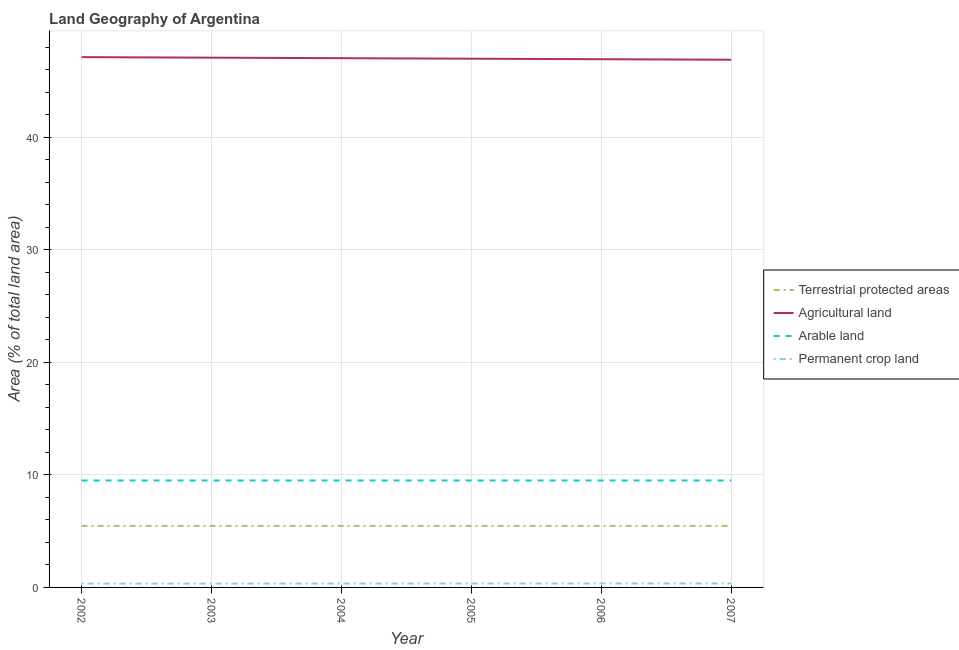How many different coloured lines are there?
Your answer should be very brief. 4. Does the line corresponding to percentage of area under arable land intersect with the line corresponding to percentage of area under permanent crop land?
Provide a succinct answer. No. What is the percentage of area under arable land in 2003?
Provide a short and direct response. 9.5. Across all years, what is the maximum percentage of area under agricultural land?
Provide a short and direct response. 47.1. Across all years, what is the minimum percentage of area under arable land?
Your answer should be compact. 9.5. What is the total percentage of area under agricultural land in the graph?
Make the answer very short. 281.92. What is the difference between the percentage of land under terrestrial protection in 2002 and the percentage of area under arable land in 2007?
Your response must be concise. -4.03. What is the average percentage of area under permanent crop land per year?
Ensure brevity in your answer.  0.35. In the year 2005, what is the difference between the percentage of area under permanent crop land and percentage of area under arable land?
Keep it short and to the point. -9.15. In how many years, is the percentage of land under terrestrial protection greater than 24 %?
Your answer should be very brief. 0. What is the ratio of the percentage of area under arable land in 2005 to that in 2006?
Offer a very short reply. 1. Is the percentage of area under arable land in 2002 less than that in 2005?
Give a very brief answer. No. Is the difference between the percentage of area under agricultural land in 2004 and 2005 greater than the difference between the percentage of land under terrestrial protection in 2004 and 2005?
Keep it short and to the point. Yes. What is the difference between the highest and the lowest percentage of land under terrestrial protection?
Keep it short and to the point. 0. Is the percentage of area under agricultural land strictly greater than the percentage of land under terrestrial protection over the years?
Your answer should be compact. Yes. Does the graph contain any zero values?
Your response must be concise. No. Does the graph contain grids?
Make the answer very short. Yes. How are the legend labels stacked?
Make the answer very short. Vertical. What is the title of the graph?
Offer a very short reply. Land Geography of Argentina. What is the label or title of the X-axis?
Keep it short and to the point. Year. What is the label or title of the Y-axis?
Ensure brevity in your answer.  Area (% of total land area). What is the Area (% of total land area) in Terrestrial protected areas in 2002?
Ensure brevity in your answer.  5.47. What is the Area (% of total land area) in Agricultural land in 2002?
Your answer should be very brief. 47.1. What is the Area (% of total land area) of Arable land in 2002?
Your answer should be very brief. 9.5. What is the Area (% of total land area) in Permanent crop land in 2002?
Your answer should be compact. 0.34. What is the Area (% of total land area) in Terrestrial protected areas in 2003?
Provide a succinct answer. 5.47. What is the Area (% of total land area) of Agricultural land in 2003?
Provide a short and direct response. 47.06. What is the Area (% of total land area) in Arable land in 2003?
Provide a short and direct response. 9.5. What is the Area (% of total land area) in Permanent crop land in 2003?
Ensure brevity in your answer.  0.35. What is the Area (% of total land area) in Terrestrial protected areas in 2004?
Your response must be concise. 5.47. What is the Area (% of total land area) in Agricultural land in 2004?
Offer a terse response. 47.01. What is the Area (% of total land area) in Arable land in 2004?
Make the answer very short. 9.5. What is the Area (% of total land area) of Permanent crop land in 2004?
Provide a succinct answer. 0.35. What is the Area (% of total land area) of Terrestrial protected areas in 2005?
Your answer should be very brief. 5.47. What is the Area (% of total land area) of Agricultural land in 2005?
Give a very brief answer. 46.96. What is the Area (% of total land area) in Arable land in 2005?
Your answer should be very brief. 9.5. What is the Area (% of total land area) in Permanent crop land in 2005?
Ensure brevity in your answer.  0.35. What is the Area (% of total land area) in Terrestrial protected areas in 2006?
Offer a terse response. 5.47. What is the Area (% of total land area) in Agricultural land in 2006?
Ensure brevity in your answer.  46.92. What is the Area (% of total land area) in Arable land in 2006?
Offer a terse response. 9.5. What is the Area (% of total land area) in Permanent crop land in 2006?
Your response must be concise. 0.35. What is the Area (% of total land area) in Terrestrial protected areas in 2007?
Keep it short and to the point. 5.47. What is the Area (% of total land area) in Agricultural land in 2007?
Offer a very short reply. 46.87. What is the Area (% of total land area) of Arable land in 2007?
Offer a very short reply. 9.5. What is the Area (% of total land area) of Permanent crop land in 2007?
Keep it short and to the point. 0.35. Across all years, what is the maximum Area (% of total land area) of Terrestrial protected areas?
Your answer should be very brief. 5.47. Across all years, what is the maximum Area (% of total land area) in Agricultural land?
Make the answer very short. 47.1. Across all years, what is the maximum Area (% of total land area) of Arable land?
Offer a very short reply. 9.5. Across all years, what is the maximum Area (% of total land area) of Permanent crop land?
Your answer should be compact. 0.35. Across all years, what is the minimum Area (% of total land area) in Terrestrial protected areas?
Provide a short and direct response. 5.47. Across all years, what is the minimum Area (% of total land area) of Agricultural land?
Give a very brief answer. 46.87. Across all years, what is the minimum Area (% of total land area) in Arable land?
Ensure brevity in your answer.  9.5. Across all years, what is the minimum Area (% of total land area) of Permanent crop land?
Your response must be concise. 0.34. What is the total Area (% of total land area) of Terrestrial protected areas in the graph?
Your response must be concise. 32.8. What is the total Area (% of total land area) of Agricultural land in the graph?
Your answer should be very brief. 281.92. What is the total Area (% of total land area) in Arable land in the graph?
Provide a short and direct response. 57. What is the total Area (% of total land area) in Permanent crop land in the graph?
Provide a short and direct response. 2.09. What is the difference between the Area (% of total land area) of Agricultural land in 2002 and that in 2003?
Make the answer very short. 0.05. What is the difference between the Area (% of total land area) in Arable land in 2002 and that in 2003?
Offer a very short reply. 0. What is the difference between the Area (% of total land area) in Permanent crop land in 2002 and that in 2003?
Give a very brief answer. -0. What is the difference between the Area (% of total land area) in Terrestrial protected areas in 2002 and that in 2004?
Ensure brevity in your answer.  0. What is the difference between the Area (% of total land area) in Agricultural land in 2002 and that in 2004?
Keep it short and to the point. 0.09. What is the difference between the Area (% of total land area) of Permanent crop land in 2002 and that in 2004?
Your response must be concise. -0. What is the difference between the Area (% of total land area) in Agricultural land in 2002 and that in 2005?
Keep it short and to the point. 0.14. What is the difference between the Area (% of total land area) in Permanent crop land in 2002 and that in 2005?
Provide a short and direct response. -0.01. What is the difference between the Area (% of total land area) of Terrestrial protected areas in 2002 and that in 2006?
Offer a terse response. 0. What is the difference between the Area (% of total land area) in Agricultural land in 2002 and that in 2006?
Give a very brief answer. 0.18. What is the difference between the Area (% of total land area) of Arable land in 2002 and that in 2006?
Offer a terse response. 0. What is the difference between the Area (% of total land area) of Permanent crop land in 2002 and that in 2006?
Your response must be concise. -0.01. What is the difference between the Area (% of total land area) of Terrestrial protected areas in 2002 and that in 2007?
Provide a short and direct response. 0. What is the difference between the Area (% of total land area) of Agricultural land in 2002 and that in 2007?
Make the answer very short. 0.23. What is the difference between the Area (% of total land area) in Permanent crop land in 2002 and that in 2007?
Make the answer very short. -0.01. What is the difference between the Area (% of total land area) in Agricultural land in 2003 and that in 2004?
Your answer should be compact. 0.05. What is the difference between the Area (% of total land area) in Permanent crop land in 2003 and that in 2004?
Offer a terse response. -0. What is the difference between the Area (% of total land area) of Agricultural land in 2003 and that in 2005?
Your answer should be compact. 0.09. What is the difference between the Area (% of total land area) of Permanent crop land in 2003 and that in 2005?
Give a very brief answer. -0. What is the difference between the Area (% of total land area) in Terrestrial protected areas in 2003 and that in 2006?
Give a very brief answer. 0. What is the difference between the Area (% of total land area) of Agricultural land in 2003 and that in 2006?
Keep it short and to the point. 0.14. What is the difference between the Area (% of total land area) of Arable land in 2003 and that in 2006?
Give a very brief answer. 0. What is the difference between the Area (% of total land area) in Permanent crop land in 2003 and that in 2006?
Offer a terse response. -0.01. What is the difference between the Area (% of total land area) of Terrestrial protected areas in 2003 and that in 2007?
Provide a short and direct response. 0. What is the difference between the Area (% of total land area) in Agricultural land in 2003 and that in 2007?
Your answer should be compact. 0.18. What is the difference between the Area (% of total land area) of Permanent crop land in 2003 and that in 2007?
Your answer should be very brief. -0.01. What is the difference between the Area (% of total land area) in Terrestrial protected areas in 2004 and that in 2005?
Your answer should be very brief. 0. What is the difference between the Area (% of total land area) in Agricultural land in 2004 and that in 2005?
Provide a succinct answer. 0.05. What is the difference between the Area (% of total land area) of Arable land in 2004 and that in 2005?
Offer a terse response. 0. What is the difference between the Area (% of total land area) of Permanent crop land in 2004 and that in 2005?
Keep it short and to the point. -0. What is the difference between the Area (% of total land area) in Agricultural land in 2004 and that in 2006?
Ensure brevity in your answer.  0.09. What is the difference between the Area (% of total land area) of Arable land in 2004 and that in 2006?
Your answer should be compact. 0. What is the difference between the Area (% of total land area) of Permanent crop land in 2004 and that in 2006?
Provide a succinct answer. -0. What is the difference between the Area (% of total land area) of Agricultural land in 2004 and that in 2007?
Your answer should be compact. 0.14. What is the difference between the Area (% of total land area) in Arable land in 2004 and that in 2007?
Give a very brief answer. 0. What is the difference between the Area (% of total land area) of Permanent crop land in 2004 and that in 2007?
Your response must be concise. -0.01. What is the difference between the Area (% of total land area) of Agricultural land in 2005 and that in 2006?
Make the answer very short. 0.05. What is the difference between the Area (% of total land area) of Permanent crop land in 2005 and that in 2006?
Offer a terse response. -0. What is the difference between the Area (% of total land area) of Agricultural land in 2005 and that in 2007?
Your answer should be very brief. 0.09. What is the difference between the Area (% of total land area) of Permanent crop land in 2005 and that in 2007?
Offer a terse response. -0. What is the difference between the Area (% of total land area) in Terrestrial protected areas in 2006 and that in 2007?
Keep it short and to the point. 0. What is the difference between the Area (% of total land area) of Agricultural land in 2006 and that in 2007?
Keep it short and to the point. 0.05. What is the difference between the Area (% of total land area) of Arable land in 2006 and that in 2007?
Keep it short and to the point. 0. What is the difference between the Area (% of total land area) in Permanent crop land in 2006 and that in 2007?
Ensure brevity in your answer.  -0. What is the difference between the Area (% of total land area) in Terrestrial protected areas in 2002 and the Area (% of total land area) in Agricultural land in 2003?
Ensure brevity in your answer.  -41.59. What is the difference between the Area (% of total land area) in Terrestrial protected areas in 2002 and the Area (% of total land area) in Arable land in 2003?
Make the answer very short. -4.03. What is the difference between the Area (% of total land area) in Terrestrial protected areas in 2002 and the Area (% of total land area) in Permanent crop land in 2003?
Offer a terse response. 5.12. What is the difference between the Area (% of total land area) in Agricultural land in 2002 and the Area (% of total land area) in Arable land in 2003?
Offer a terse response. 37.6. What is the difference between the Area (% of total land area) of Agricultural land in 2002 and the Area (% of total land area) of Permanent crop land in 2003?
Provide a short and direct response. 46.76. What is the difference between the Area (% of total land area) of Arable land in 2002 and the Area (% of total land area) of Permanent crop land in 2003?
Ensure brevity in your answer.  9.15. What is the difference between the Area (% of total land area) of Terrestrial protected areas in 2002 and the Area (% of total land area) of Agricultural land in 2004?
Give a very brief answer. -41.54. What is the difference between the Area (% of total land area) in Terrestrial protected areas in 2002 and the Area (% of total land area) in Arable land in 2004?
Offer a terse response. -4.03. What is the difference between the Area (% of total land area) of Terrestrial protected areas in 2002 and the Area (% of total land area) of Permanent crop land in 2004?
Ensure brevity in your answer.  5.12. What is the difference between the Area (% of total land area) of Agricultural land in 2002 and the Area (% of total land area) of Arable land in 2004?
Your response must be concise. 37.6. What is the difference between the Area (% of total land area) in Agricultural land in 2002 and the Area (% of total land area) in Permanent crop land in 2004?
Keep it short and to the point. 46.75. What is the difference between the Area (% of total land area) in Arable land in 2002 and the Area (% of total land area) in Permanent crop land in 2004?
Ensure brevity in your answer.  9.15. What is the difference between the Area (% of total land area) in Terrestrial protected areas in 2002 and the Area (% of total land area) in Agricultural land in 2005?
Your answer should be compact. -41.5. What is the difference between the Area (% of total land area) in Terrestrial protected areas in 2002 and the Area (% of total land area) in Arable land in 2005?
Give a very brief answer. -4.03. What is the difference between the Area (% of total land area) of Terrestrial protected areas in 2002 and the Area (% of total land area) of Permanent crop land in 2005?
Provide a short and direct response. 5.12. What is the difference between the Area (% of total land area) in Agricultural land in 2002 and the Area (% of total land area) in Arable land in 2005?
Offer a very short reply. 37.6. What is the difference between the Area (% of total land area) in Agricultural land in 2002 and the Area (% of total land area) in Permanent crop land in 2005?
Provide a succinct answer. 46.75. What is the difference between the Area (% of total land area) of Arable land in 2002 and the Area (% of total land area) of Permanent crop land in 2005?
Ensure brevity in your answer.  9.15. What is the difference between the Area (% of total land area) in Terrestrial protected areas in 2002 and the Area (% of total land area) in Agricultural land in 2006?
Your answer should be very brief. -41.45. What is the difference between the Area (% of total land area) in Terrestrial protected areas in 2002 and the Area (% of total land area) in Arable land in 2006?
Your answer should be compact. -4.03. What is the difference between the Area (% of total land area) of Terrestrial protected areas in 2002 and the Area (% of total land area) of Permanent crop land in 2006?
Make the answer very short. 5.11. What is the difference between the Area (% of total land area) in Agricultural land in 2002 and the Area (% of total land area) in Arable land in 2006?
Offer a terse response. 37.6. What is the difference between the Area (% of total land area) of Agricultural land in 2002 and the Area (% of total land area) of Permanent crop land in 2006?
Keep it short and to the point. 46.75. What is the difference between the Area (% of total land area) of Arable land in 2002 and the Area (% of total land area) of Permanent crop land in 2006?
Your response must be concise. 9.15. What is the difference between the Area (% of total land area) of Terrestrial protected areas in 2002 and the Area (% of total land area) of Agricultural land in 2007?
Make the answer very short. -41.4. What is the difference between the Area (% of total land area) of Terrestrial protected areas in 2002 and the Area (% of total land area) of Arable land in 2007?
Your answer should be very brief. -4.03. What is the difference between the Area (% of total land area) in Terrestrial protected areas in 2002 and the Area (% of total land area) in Permanent crop land in 2007?
Make the answer very short. 5.11. What is the difference between the Area (% of total land area) in Agricultural land in 2002 and the Area (% of total land area) in Arable land in 2007?
Provide a succinct answer. 37.6. What is the difference between the Area (% of total land area) of Agricultural land in 2002 and the Area (% of total land area) of Permanent crop land in 2007?
Provide a succinct answer. 46.75. What is the difference between the Area (% of total land area) in Arable land in 2002 and the Area (% of total land area) in Permanent crop land in 2007?
Your answer should be very brief. 9.15. What is the difference between the Area (% of total land area) in Terrestrial protected areas in 2003 and the Area (% of total land area) in Agricultural land in 2004?
Provide a short and direct response. -41.54. What is the difference between the Area (% of total land area) of Terrestrial protected areas in 2003 and the Area (% of total land area) of Arable land in 2004?
Give a very brief answer. -4.03. What is the difference between the Area (% of total land area) of Terrestrial protected areas in 2003 and the Area (% of total land area) of Permanent crop land in 2004?
Provide a succinct answer. 5.12. What is the difference between the Area (% of total land area) of Agricultural land in 2003 and the Area (% of total land area) of Arable land in 2004?
Offer a very short reply. 37.55. What is the difference between the Area (% of total land area) of Agricultural land in 2003 and the Area (% of total land area) of Permanent crop land in 2004?
Provide a short and direct response. 46.71. What is the difference between the Area (% of total land area) of Arable land in 2003 and the Area (% of total land area) of Permanent crop land in 2004?
Give a very brief answer. 9.15. What is the difference between the Area (% of total land area) of Terrestrial protected areas in 2003 and the Area (% of total land area) of Agricultural land in 2005?
Your answer should be very brief. -41.5. What is the difference between the Area (% of total land area) in Terrestrial protected areas in 2003 and the Area (% of total land area) in Arable land in 2005?
Give a very brief answer. -4.03. What is the difference between the Area (% of total land area) of Terrestrial protected areas in 2003 and the Area (% of total land area) of Permanent crop land in 2005?
Provide a succinct answer. 5.12. What is the difference between the Area (% of total land area) in Agricultural land in 2003 and the Area (% of total land area) in Arable land in 2005?
Offer a very short reply. 37.55. What is the difference between the Area (% of total land area) of Agricultural land in 2003 and the Area (% of total land area) of Permanent crop land in 2005?
Ensure brevity in your answer.  46.71. What is the difference between the Area (% of total land area) in Arable land in 2003 and the Area (% of total land area) in Permanent crop land in 2005?
Keep it short and to the point. 9.15. What is the difference between the Area (% of total land area) in Terrestrial protected areas in 2003 and the Area (% of total land area) in Agricultural land in 2006?
Keep it short and to the point. -41.45. What is the difference between the Area (% of total land area) in Terrestrial protected areas in 2003 and the Area (% of total land area) in Arable land in 2006?
Your response must be concise. -4.03. What is the difference between the Area (% of total land area) in Terrestrial protected areas in 2003 and the Area (% of total land area) in Permanent crop land in 2006?
Give a very brief answer. 5.11. What is the difference between the Area (% of total land area) in Agricultural land in 2003 and the Area (% of total land area) in Arable land in 2006?
Your answer should be compact. 37.55. What is the difference between the Area (% of total land area) in Agricultural land in 2003 and the Area (% of total land area) in Permanent crop land in 2006?
Your answer should be compact. 46.7. What is the difference between the Area (% of total land area) in Arable land in 2003 and the Area (% of total land area) in Permanent crop land in 2006?
Ensure brevity in your answer.  9.15. What is the difference between the Area (% of total land area) of Terrestrial protected areas in 2003 and the Area (% of total land area) of Agricultural land in 2007?
Offer a terse response. -41.4. What is the difference between the Area (% of total land area) in Terrestrial protected areas in 2003 and the Area (% of total land area) in Arable land in 2007?
Ensure brevity in your answer.  -4.03. What is the difference between the Area (% of total land area) of Terrestrial protected areas in 2003 and the Area (% of total land area) of Permanent crop land in 2007?
Offer a terse response. 5.11. What is the difference between the Area (% of total land area) of Agricultural land in 2003 and the Area (% of total land area) of Arable land in 2007?
Make the answer very short. 37.55. What is the difference between the Area (% of total land area) in Agricultural land in 2003 and the Area (% of total land area) in Permanent crop land in 2007?
Make the answer very short. 46.7. What is the difference between the Area (% of total land area) of Arable land in 2003 and the Area (% of total land area) of Permanent crop land in 2007?
Keep it short and to the point. 9.15. What is the difference between the Area (% of total land area) in Terrestrial protected areas in 2004 and the Area (% of total land area) in Agricultural land in 2005?
Keep it short and to the point. -41.5. What is the difference between the Area (% of total land area) in Terrestrial protected areas in 2004 and the Area (% of total land area) in Arable land in 2005?
Your response must be concise. -4.03. What is the difference between the Area (% of total land area) in Terrestrial protected areas in 2004 and the Area (% of total land area) in Permanent crop land in 2005?
Your answer should be compact. 5.12. What is the difference between the Area (% of total land area) of Agricultural land in 2004 and the Area (% of total land area) of Arable land in 2005?
Give a very brief answer. 37.51. What is the difference between the Area (% of total land area) in Agricultural land in 2004 and the Area (% of total land area) in Permanent crop land in 2005?
Give a very brief answer. 46.66. What is the difference between the Area (% of total land area) in Arable land in 2004 and the Area (% of total land area) in Permanent crop land in 2005?
Ensure brevity in your answer.  9.15. What is the difference between the Area (% of total land area) in Terrestrial protected areas in 2004 and the Area (% of total land area) in Agricultural land in 2006?
Offer a very short reply. -41.45. What is the difference between the Area (% of total land area) in Terrestrial protected areas in 2004 and the Area (% of total land area) in Arable land in 2006?
Your response must be concise. -4.03. What is the difference between the Area (% of total land area) of Terrestrial protected areas in 2004 and the Area (% of total land area) of Permanent crop land in 2006?
Your response must be concise. 5.11. What is the difference between the Area (% of total land area) of Agricultural land in 2004 and the Area (% of total land area) of Arable land in 2006?
Provide a succinct answer. 37.51. What is the difference between the Area (% of total land area) of Agricultural land in 2004 and the Area (% of total land area) of Permanent crop land in 2006?
Your answer should be very brief. 46.66. What is the difference between the Area (% of total land area) in Arable land in 2004 and the Area (% of total land area) in Permanent crop land in 2006?
Make the answer very short. 9.15. What is the difference between the Area (% of total land area) of Terrestrial protected areas in 2004 and the Area (% of total land area) of Agricultural land in 2007?
Offer a terse response. -41.4. What is the difference between the Area (% of total land area) of Terrestrial protected areas in 2004 and the Area (% of total land area) of Arable land in 2007?
Ensure brevity in your answer.  -4.03. What is the difference between the Area (% of total land area) of Terrestrial protected areas in 2004 and the Area (% of total land area) of Permanent crop land in 2007?
Ensure brevity in your answer.  5.11. What is the difference between the Area (% of total land area) in Agricultural land in 2004 and the Area (% of total land area) in Arable land in 2007?
Provide a succinct answer. 37.51. What is the difference between the Area (% of total land area) of Agricultural land in 2004 and the Area (% of total land area) of Permanent crop land in 2007?
Make the answer very short. 46.66. What is the difference between the Area (% of total land area) in Arable land in 2004 and the Area (% of total land area) in Permanent crop land in 2007?
Your answer should be compact. 9.15. What is the difference between the Area (% of total land area) in Terrestrial protected areas in 2005 and the Area (% of total land area) in Agricultural land in 2006?
Give a very brief answer. -41.45. What is the difference between the Area (% of total land area) of Terrestrial protected areas in 2005 and the Area (% of total land area) of Arable land in 2006?
Offer a very short reply. -4.03. What is the difference between the Area (% of total land area) of Terrestrial protected areas in 2005 and the Area (% of total land area) of Permanent crop land in 2006?
Provide a succinct answer. 5.11. What is the difference between the Area (% of total land area) of Agricultural land in 2005 and the Area (% of total land area) of Arable land in 2006?
Keep it short and to the point. 37.46. What is the difference between the Area (% of total land area) in Agricultural land in 2005 and the Area (% of total land area) in Permanent crop land in 2006?
Make the answer very short. 46.61. What is the difference between the Area (% of total land area) of Arable land in 2005 and the Area (% of total land area) of Permanent crop land in 2006?
Ensure brevity in your answer.  9.15. What is the difference between the Area (% of total land area) in Terrestrial protected areas in 2005 and the Area (% of total land area) in Agricultural land in 2007?
Offer a very short reply. -41.4. What is the difference between the Area (% of total land area) in Terrestrial protected areas in 2005 and the Area (% of total land area) in Arable land in 2007?
Provide a succinct answer. -4.03. What is the difference between the Area (% of total land area) in Terrestrial protected areas in 2005 and the Area (% of total land area) in Permanent crop land in 2007?
Your answer should be very brief. 5.11. What is the difference between the Area (% of total land area) of Agricultural land in 2005 and the Area (% of total land area) of Arable land in 2007?
Provide a short and direct response. 37.46. What is the difference between the Area (% of total land area) of Agricultural land in 2005 and the Area (% of total land area) of Permanent crop land in 2007?
Offer a terse response. 46.61. What is the difference between the Area (% of total land area) of Arable land in 2005 and the Area (% of total land area) of Permanent crop land in 2007?
Offer a terse response. 9.15. What is the difference between the Area (% of total land area) of Terrestrial protected areas in 2006 and the Area (% of total land area) of Agricultural land in 2007?
Your response must be concise. -41.4. What is the difference between the Area (% of total land area) of Terrestrial protected areas in 2006 and the Area (% of total land area) of Arable land in 2007?
Keep it short and to the point. -4.03. What is the difference between the Area (% of total land area) of Terrestrial protected areas in 2006 and the Area (% of total land area) of Permanent crop land in 2007?
Provide a short and direct response. 5.11. What is the difference between the Area (% of total land area) in Agricultural land in 2006 and the Area (% of total land area) in Arable land in 2007?
Your answer should be compact. 37.42. What is the difference between the Area (% of total land area) of Agricultural land in 2006 and the Area (% of total land area) of Permanent crop land in 2007?
Provide a succinct answer. 46.56. What is the difference between the Area (% of total land area) of Arable land in 2006 and the Area (% of total land area) of Permanent crop land in 2007?
Offer a very short reply. 9.15. What is the average Area (% of total land area) in Terrestrial protected areas per year?
Offer a terse response. 5.47. What is the average Area (% of total land area) of Agricultural land per year?
Offer a very short reply. 46.99. What is the average Area (% of total land area) of Arable land per year?
Offer a very short reply. 9.5. What is the average Area (% of total land area) of Permanent crop land per year?
Provide a short and direct response. 0.35. In the year 2002, what is the difference between the Area (% of total land area) of Terrestrial protected areas and Area (% of total land area) of Agricultural land?
Ensure brevity in your answer.  -41.63. In the year 2002, what is the difference between the Area (% of total land area) in Terrestrial protected areas and Area (% of total land area) in Arable land?
Provide a short and direct response. -4.03. In the year 2002, what is the difference between the Area (% of total land area) in Terrestrial protected areas and Area (% of total land area) in Permanent crop land?
Ensure brevity in your answer.  5.12. In the year 2002, what is the difference between the Area (% of total land area) in Agricultural land and Area (% of total land area) in Arable land?
Offer a very short reply. 37.6. In the year 2002, what is the difference between the Area (% of total land area) in Agricultural land and Area (% of total land area) in Permanent crop land?
Ensure brevity in your answer.  46.76. In the year 2002, what is the difference between the Area (% of total land area) in Arable land and Area (% of total land area) in Permanent crop land?
Offer a very short reply. 9.16. In the year 2003, what is the difference between the Area (% of total land area) in Terrestrial protected areas and Area (% of total land area) in Agricultural land?
Provide a short and direct response. -41.59. In the year 2003, what is the difference between the Area (% of total land area) in Terrestrial protected areas and Area (% of total land area) in Arable land?
Offer a terse response. -4.03. In the year 2003, what is the difference between the Area (% of total land area) in Terrestrial protected areas and Area (% of total land area) in Permanent crop land?
Give a very brief answer. 5.12. In the year 2003, what is the difference between the Area (% of total land area) of Agricultural land and Area (% of total land area) of Arable land?
Provide a short and direct response. 37.55. In the year 2003, what is the difference between the Area (% of total land area) of Agricultural land and Area (% of total land area) of Permanent crop land?
Keep it short and to the point. 46.71. In the year 2003, what is the difference between the Area (% of total land area) of Arable land and Area (% of total land area) of Permanent crop land?
Provide a succinct answer. 9.15. In the year 2004, what is the difference between the Area (% of total land area) of Terrestrial protected areas and Area (% of total land area) of Agricultural land?
Provide a short and direct response. -41.54. In the year 2004, what is the difference between the Area (% of total land area) in Terrestrial protected areas and Area (% of total land area) in Arable land?
Ensure brevity in your answer.  -4.03. In the year 2004, what is the difference between the Area (% of total land area) in Terrestrial protected areas and Area (% of total land area) in Permanent crop land?
Make the answer very short. 5.12. In the year 2004, what is the difference between the Area (% of total land area) of Agricultural land and Area (% of total land area) of Arable land?
Keep it short and to the point. 37.51. In the year 2004, what is the difference between the Area (% of total land area) of Agricultural land and Area (% of total land area) of Permanent crop land?
Keep it short and to the point. 46.66. In the year 2004, what is the difference between the Area (% of total land area) of Arable land and Area (% of total land area) of Permanent crop land?
Your answer should be very brief. 9.15. In the year 2005, what is the difference between the Area (% of total land area) of Terrestrial protected areas and Area (% of total land area) of Agricultural land?
Ensure brevity in your answer.  -41.5. In the year 2005, what is the difference between the Area (% of total land area) of Terrestrial protected areas and Area (% of total land area) of Arable land?
Ensure brevity in your answer.  -4.03. In the year 2005, what is the difference between the Area (% of total land area) in Terrestrial protected areas and Area (% of total land area) in Permanent crop land?
Give a very brief answer. 5.12. In the year 2005, what is the difference between the Area (% of total land area) in Agricultural land and Area (% of total land area) in Arable land?
Give a very brief answer. 37.46. In the year 2005, what is the difference between the Area (% of total land area) of Agricultural land and Area (% of total land area) of Permanent crop land?
Keep it short and to the point. 46.61. In the year 2005, what is the difference between the Area (% of total land area) in Arable land and Area (% of total land area) in Permanent crop land?
Your response must be concise. 9.15. In the year 2006, what is the difference between the Area (% of total land area) of Terrestrial protected areas and Area (% of total land area) of Agricultural land?
Your answer should be compact. -41.45. In the year 2006, what is the difference between the Area (% of total land area) of Terrestrial protected areas and Area (% of total land area) of Arable land?
Keep it short and to the point. -4.03. In the year 2006, what is the difference between the Area (% of total land area) of Terrestrial protected areas and Area (% of total land area) of Permanent crop land?
Your answer should be compact. 5.11. In the year 2006, what is the difference between the Area (% of total land area) in Agricultural land and Area (% of total land area) in Arable land?
Provide a succinct answer. 37.42. In the year 2006, what is the difference between the Area (% of total land area) in Agricultural land and Area (% of total land area) in Permanent crop land?
Your response must be concise. 46.56. In the year 2006, what is the difference between the Area (% of total land area) in Arable land and Area (% of total land area) in Permanent crop land?
Your answer should be compact. 9.15. In the year 2007, what is the difference between the Area (% of total land area) of Terrestrial protected areas and Area (% of total land area) of Agricultural land?
Offer a terse response. -41.4. In the year 2007, what is the difference between the Area (% of total land area) in Terrestrial protected areas and Area (% of total land area) in Arable land?
Your response must be concise. -4.03. In the year 2007, what is the difference between the Area (% of total land area) in Terrestrial protected areas and Area (% of total land area) in Permanent crop land?
Your answer should be compact. 5.11. In the year 2007, what is the difference between the Area (% of total land area) in Agricultural land and Area (% of total land area) in Arable land?
Offer a terse response. 37.37. In the year 2007, what is the difference between the Area (% of total land area) of Agricultural land and Area (% of total land area) of Permanent crop land?
Provide a short and direct response. 46.52. In the year 2007, what is the difference between the Area (% of total land area) in Arable land and Area (% of total land area) in Permanent crop land?
Your response must be concise. 9.15. What is the ratio of the Area (% of total land area) in Agricultural land in 2002 to that in 2004?
Your answer should be very brief. 1. What is the ratio of the Area (% of total land area) of Permanent crop land in 2002 to that in 2005?
Provide a short and direct response. 0.98. What is the ratio of the Area (% of total land area) in Agricultural land in 2002 to that in 2006?
Provide a short and direct response. 1. What is the ratio of the Area (% of total land area) in Arable land in 2002 to that in 2006?
Ensure brevity in your answer.  1. What is the ratio of the Area (% of total land area) of Permanent crop land in 2002 to that in 2006?
Your answer should be very brief. 0.98. What is the ratio of the Area (% of total land area) of Terrestrial protected areas in 2002 to that in 2007?
Offer a very short reply. 1. What is the ratio of the Area (% of total land area) of Permanent crop land in 2002 to that in 2007?
Your response must be concise. 0.97. What is the ratio of the Area (% of total land area) in Terrestrial protected areas in 2003 to that in 2004?
Make the answer very short. 1. What is the ratio of the Area (% of total land area) of Permanent crop land in 2003 to that in 2004?
Provide a succinct answer. 0.99. What is the ratio of the Area (% of total land area) in Terrestrial protected areas in 2003 to that in 2005?
Keep it short and to the point. 1. What is the ratio of the Area (% of total land area) of Agricultural land in 2003 to that in 2005?
Ensure brevity in your answer.  1. What is the ratio of the Area (% of total land area) of Arable land in 2003 to that in 2005?
Your answer should be very brief. 1. What is the ratio of the Area (% of total land area) of Permanent crop land in 2003 to that in 2006?
Ensure brevity in your answer.  0.98. What is the ratio of the Area (% of total land area) of Terrestrial protected areas in 2003 to that in 2007?
Your response must be concise. 1. What is the ratio of the Area (% of total land area) of Permanent crop land in 2003 to that in 2007?
Provide a short and direct response. 0.98. What is the ratio of the Area (% of total land area) in Agricultural land in 2004 to that in 2005?
Keep it short and to the point. 1. What is the ratio of the Area (% of total land area) in Agricultural land in 2004 to that in 2007?
Your answer should be very brief. 1. What is the ratio of the Area (% of total land area) in Arable land in 2004 to that in 2007?
Offer a terse response. 1. What is the ratio of the Area (% of total land area) in Permanent crop land in 2004 to that in 2007?
Give a very brief answer. 0.98. What is the ratio of the Area (% of total land area) of Terrestrial protected areas in 2005 to that in 2006?
Give a very brief answer. 1. What is the ratio of the Area (% of total land area) of Agricultural land in 2005 to that in 2006?
Keep it short and to the point. 1. What is the ratio of the Area (% of total land area) of Arable land in 2005 to that in 2006?
Give a very brief answer. 1. What is the ratio of the Area (% of total land area) in Permanent crop land in 2005 to that in 2006?
Your answer should be compact. 0.99. What is the ratio of the Area (% of total land area) of Terrestrial protected areas in 2005 to that in 2007?
Your answer should be very brief. 1. What is the ratio of the Area (% of total land area) in Agricultural land in 2005 to that in 2007?
Your answer should be compact. 1. What is the ratio of the Area (% of total land area) in Permanent crop land in 2005 to that in 2007?
Keep it short and to the point. 0.99. What is the ratio of the Area (% of total land area) in Terrestrial protected areas in 2006 to that in 2007?
Make the answer very short. 1. What is the ratio of the Area (% of total land area) in Arable land in 2006 to that in 2007?
Keep it short and to the point. 1. What is the ratio of the Area (% of total land area) of Permanent crop land in 2006 to that in 2007?
Your answer should be compact. 0.99. What is the difference between the highest and the second highest Area (% of total land area) in Terrestrial protected areas?
Provide a short and direct response. 0. What is the difference between the highest and the second highest Area (% of total land area) of Agricultural land?
Offer a very short reply. 0.05. What is the difference between the highest and the second highest Area (% of total land area) of Arable land?
Provide a succinct answer. 0. What is the difference between the highest and the second highest Area (% of total land area) in Permanent crop land?
Offer a terse response. 0. What is the difference between the highest and the lowest Area (% of total land area) of Terrestrial protected areas?
Make the answer very short. 0. What is the difference between the highest and the lowest Area (% of total land area) of Agricultural land?
Offer a very short reply. 0.23. What is the difference between the highest and the lowest Area (% of total land area) in Arable land?
Make the answer very short. 0. What is the difference between the highest and the lowest Area (% of total land area) of Permanent crop land?
Keep it short and to the point. 0.01. 